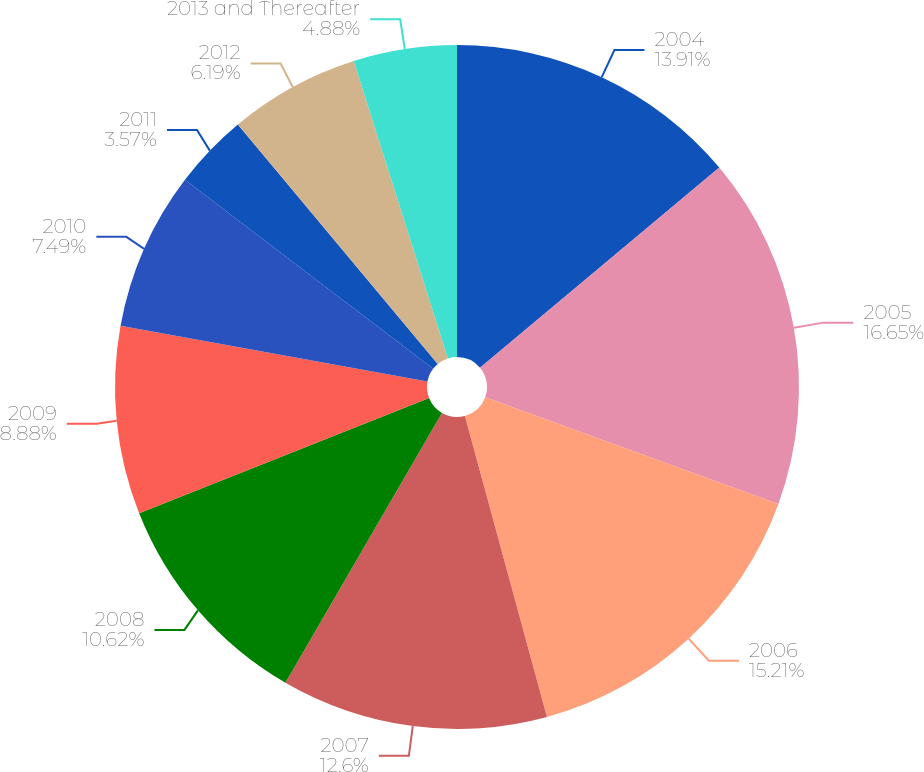Convert chart. <chart><loc_0><loc_0><loc_500><loc_500><pie_chart><fcel>2004<fcel>2005<fcel>2006<fcel>2007<fcel>2008<fcel>2009<fcel>2010<fcel>2011<fcel>2012<fcel>2013 and Thereafter<nl><fcel>13.91%<fcel>16.64%<fcel>15.21%<fcel>12.6%<fcel>10.62%<fcel>8.88%<fcel>7.49%<fcel>3.57%<fcel>6.19%<fcel>4.88%<nl></chart> 